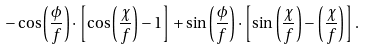<formula> <loc_0><loc_0><loc_500><loc_500>- \cos \left ( \frac { \phi } { f } \right ) \cdot \left [ \cos \left ( \frac { \chi } { f } \right ) - 1 \right ] + \sin \left ( \frac { \phi } { f } \right ) \cdot \left [ \sin \left ( \frac { \chi } { f } \right ) - \left ( \frac { \chi } { f } \right ) \right ] .</formula> 